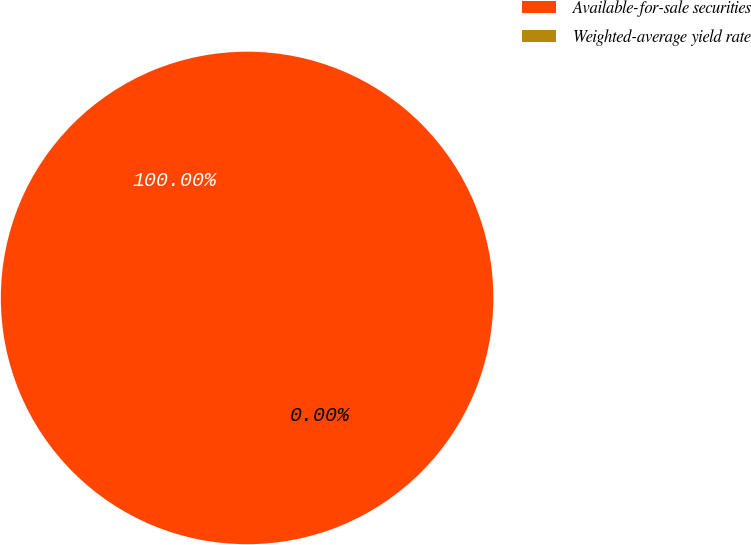Convert chart to OTSL. <chart><loc_0><loc_0><loc_500><loc_500><pie_chart><fcel>Available-for-sale securities<fcel>Weighted-average yield rate<nl><fcel>100.0%<fcel>0.0%<nl></chart> 